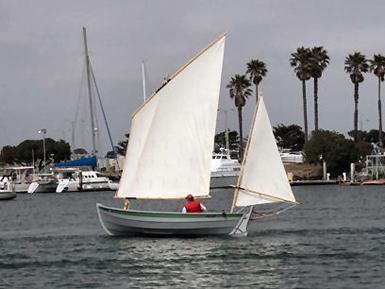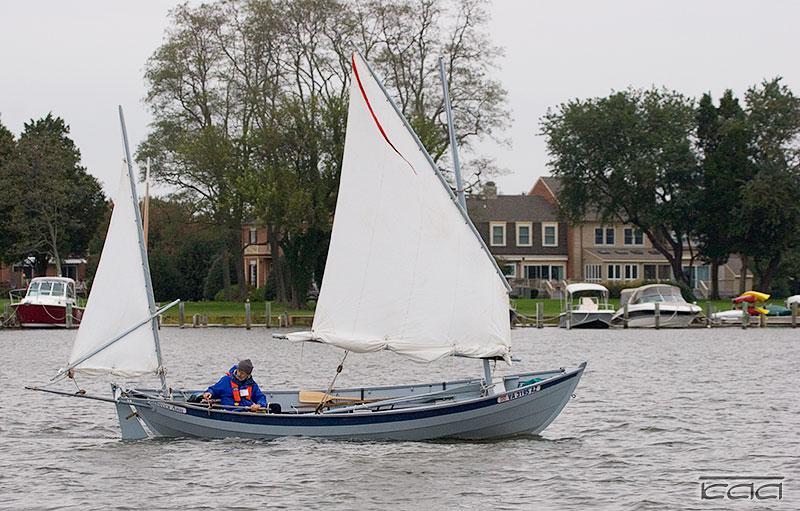The first image is the image on the left, the second image is the image on the right. For the images displayed, is the sentence "the sails in the image on the right do not have the color white on them." factually correct? Answer yes or no. No. 